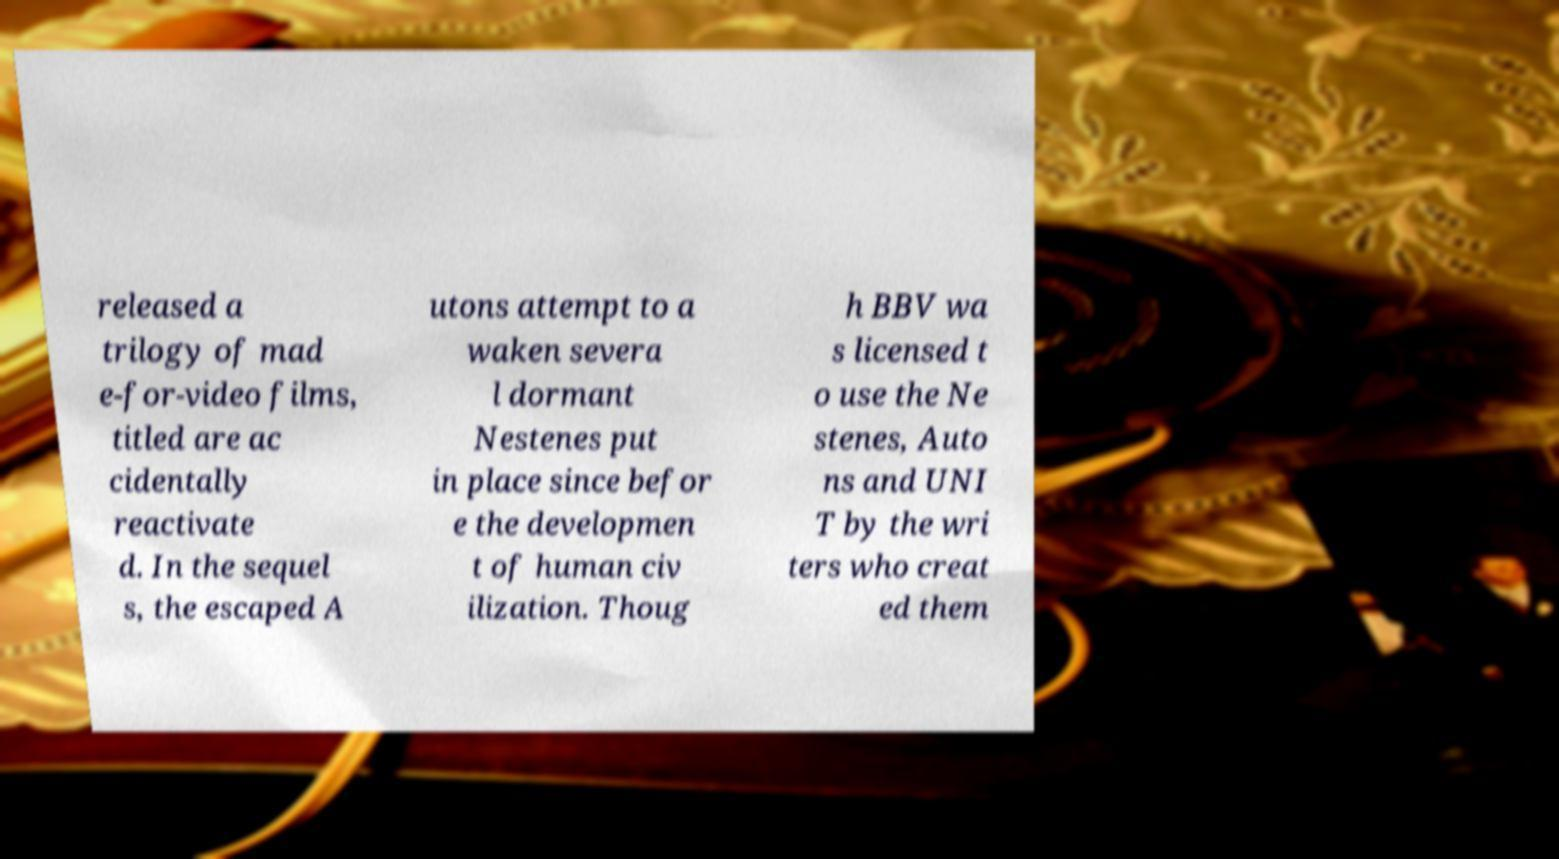What messages or text are displayed in this image? I need them in a readable, typed format. released a trilogy of mad e-for-video films, titled are ac cidentally reactivate d. In the sequel s, the escaped A utons attempt to a waken severa l dormant Nestenes put in place since befor e the developmen t of human civ ilization. Thoug h BBV wa s licensed t o use the Ne stenes, Auto ns and UNI T by the wri ters who creat ed them 